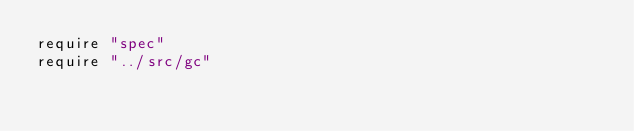Convert code to text. <code><loc_0><loc_0><loc_500><loc_500><_Crystal_>require "spec"
require "../src/gc"
</code> 